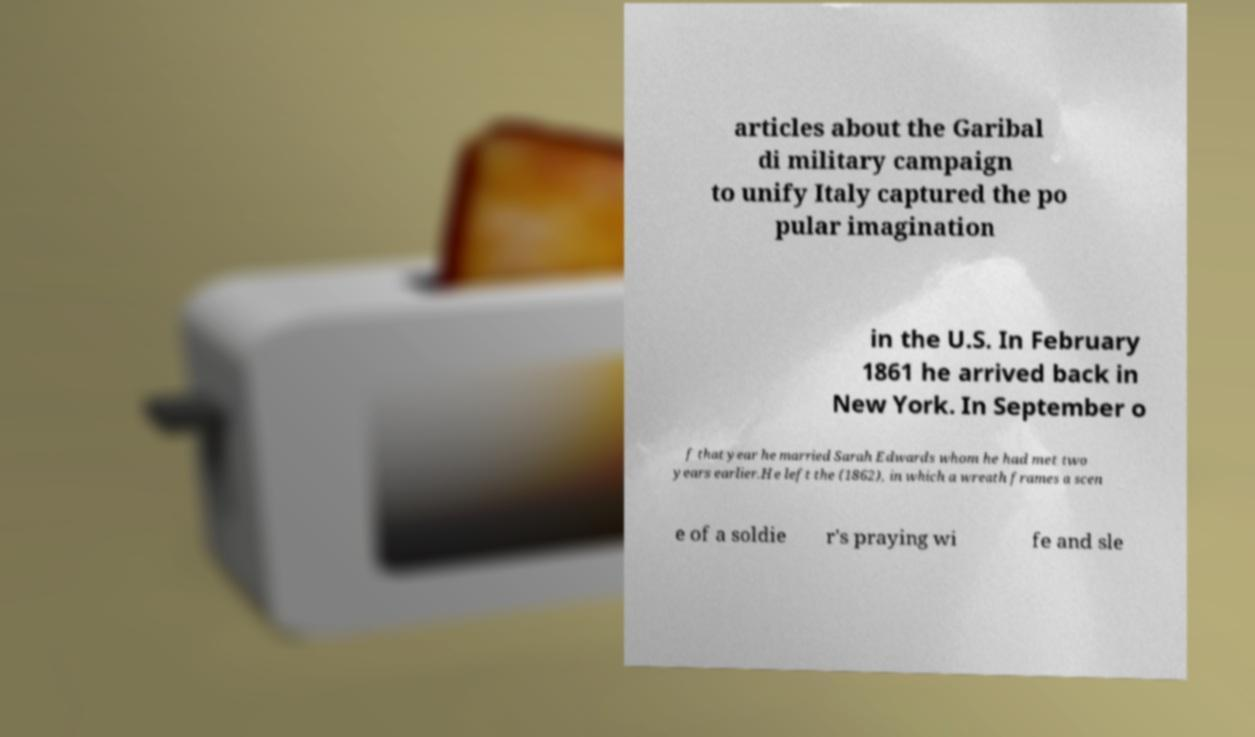Can you accurately transcribe the text from the provided image for me? articles about the Garibal di military campaign to unify Italy captured the po pular imagination in the U.S. In February 1861 he arrived back in New York. In September o f that year he married Sarah Edwards whom he had met two years earlier.He left the (1862), in which a wreath frames a scen e of a soldie r's praying wi fe and sle 